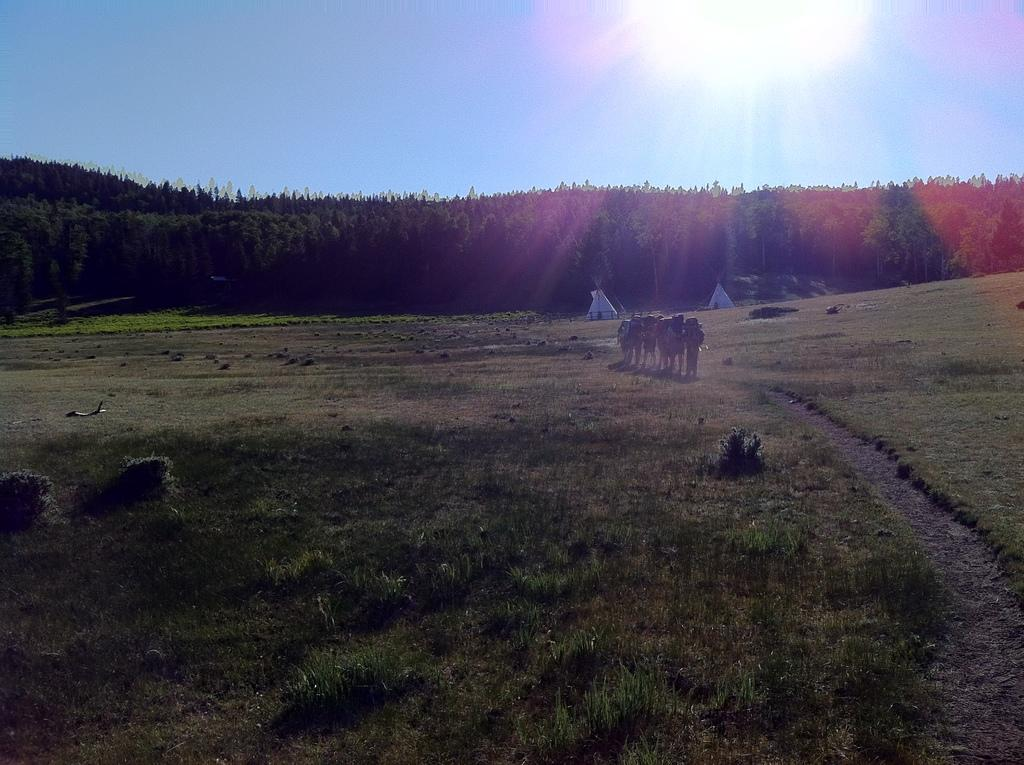What is happening in the image? There is a group of people standing in the image. What can be seen in the background of the image? There are trees in the background of the image. What is the color of the trees? The trees are green. What is the color of the sky in the image? The sky is blue. Can you see a frog hopping in the wilderness in the image? There is no frog or wilderness present in the image; it features a group of people standing with green trees in the background and a blue sky. 